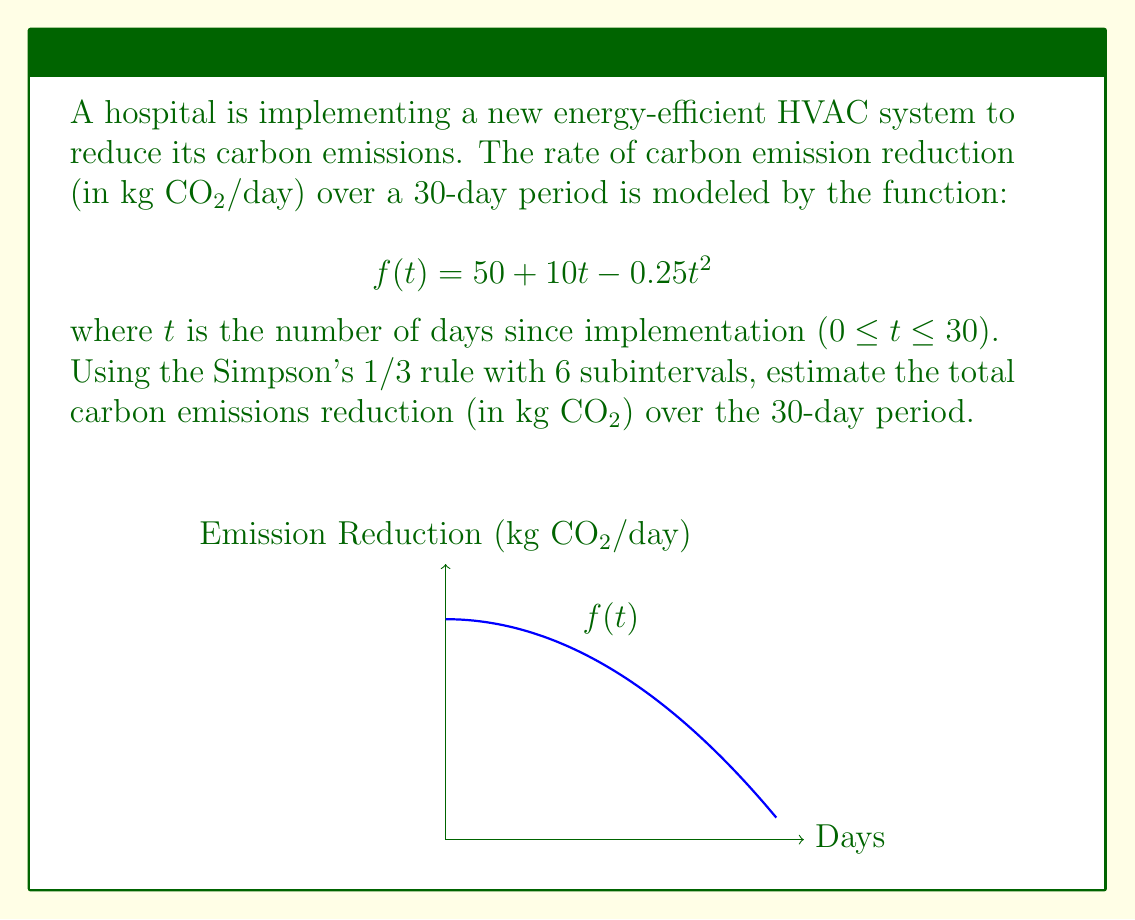Teach me how to tackle this problem. To solve this problem using Simpson's 1/3 rule with 6 subintervals:

1) The interval is [0, 30], so we divide it into 6 equal subintervals:
   $h = \frac{30 - 0}{6} = 5$

2) The x-values are: $x_0 = 0, x_1 = 5, x_2 = 10, x_3 = 15, x_4 = 20, x_5 = 25, x_6 = 30$

3) Calculate f(x) for each x-value:
   $f(0) = 50 + 10(0) - 0.25(0)^2 = 50$
   $f(5) = 50 + 10(5) - 0.25(5)^2 = 93.75$
   $f(10) = 50 + 10(10) - 0.25(10)^2 = 125$
   $f(15) = 50 + 10(15) - 0.25(15)^2 = 143.75$
   $f(20) = 50 + 10(20) - 0.25(20)^2 = 150$
   $f(25) = 50 + 10(25) - 0.25(25)^2 = 143.75$
   $f(30) = 50 + 10(30) - 0.25(30)^2 = 125$

4) Apply Simpson's 1/3 rule:
   $$\int_a^b f(x)dx \approx \frac{h}{3}[f(x_0) + 4f(x_1) + 2f(x_2) + 4f(x_3) + 2f(x_4) + 4f(x_5) + f(x_6)]$$

5) Substitute the values:
   $$\frac{5}{3}[50 + 4(93.75) + 2(125) + 4(143.75) + 2(150) + 4(143.75) + 125]$$

6) Calculate:
   $$\frac{5}{3}[50 + 375 + 250 + 575 + 300 + 575 + 125] = \frac{5}{3}(2250) = 3750$$

Therefore, the estimated total carbon emissions reduction over the 30-day period is 3750 kg CO₂.
Answer: 3750 kg CO₂ 